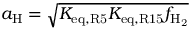<formula> <loc_0><loc_0><loc_500><loc_500>a _ { H } = \sqrt { K _ { e q , R 5 } K _ { e q , R 1 5 } f _ { H _ { 2 } } }</formula> 